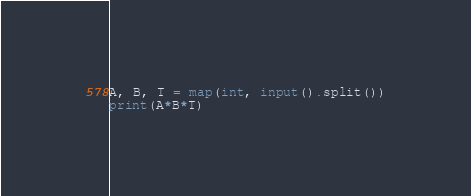Convert code to text. <code><loc_0><loc_0><loc_500><loc_500><_Python_>A, B, T = map(int, input().split())
print(A*B*T)</code> 